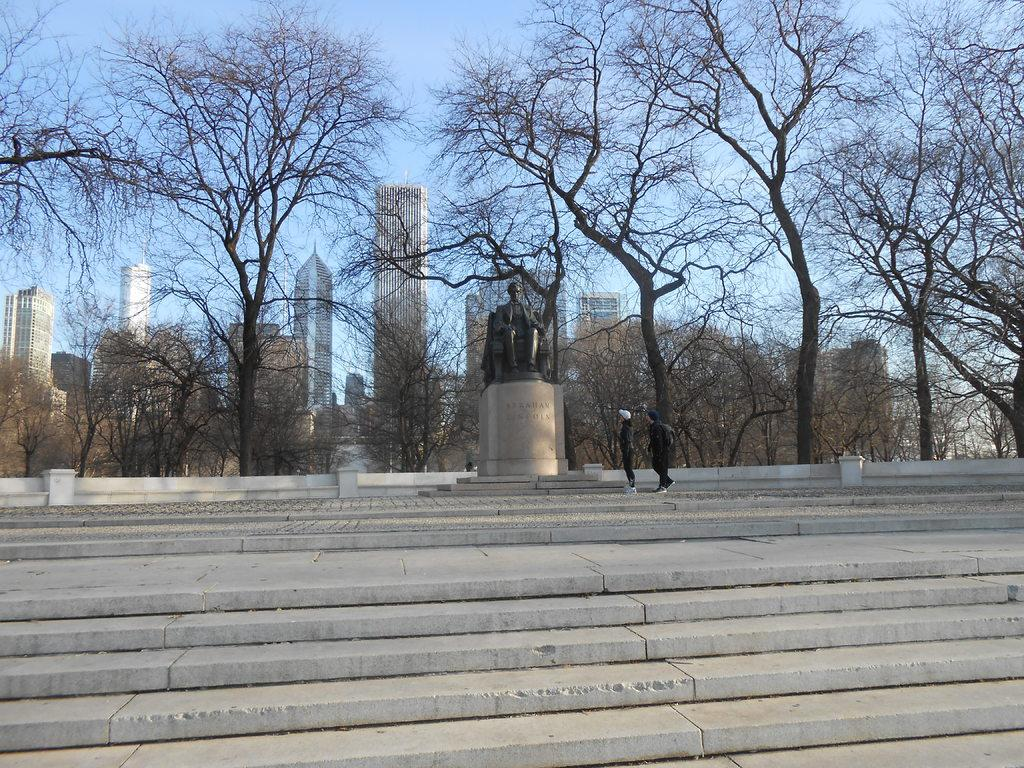What type of structure is present in the image? There is a staircase in the image. What artistic object can be seen in the image? A sculpture is visible in the image. Who is present in front of the sculpture? There are two persons in front of the sculpture. What can be seen at the top of the image? Trees, buildings, and the sky are visible at the top of the image. What is the tax rate for the sculpture in the image? There is no tax rate mentioned or implied in the image, as it is a visual representation of a sculpture and not a financial document. What shape is the maid in the image? There is no maid present in the image; it features a staircase, a sculpture, and two persons. 